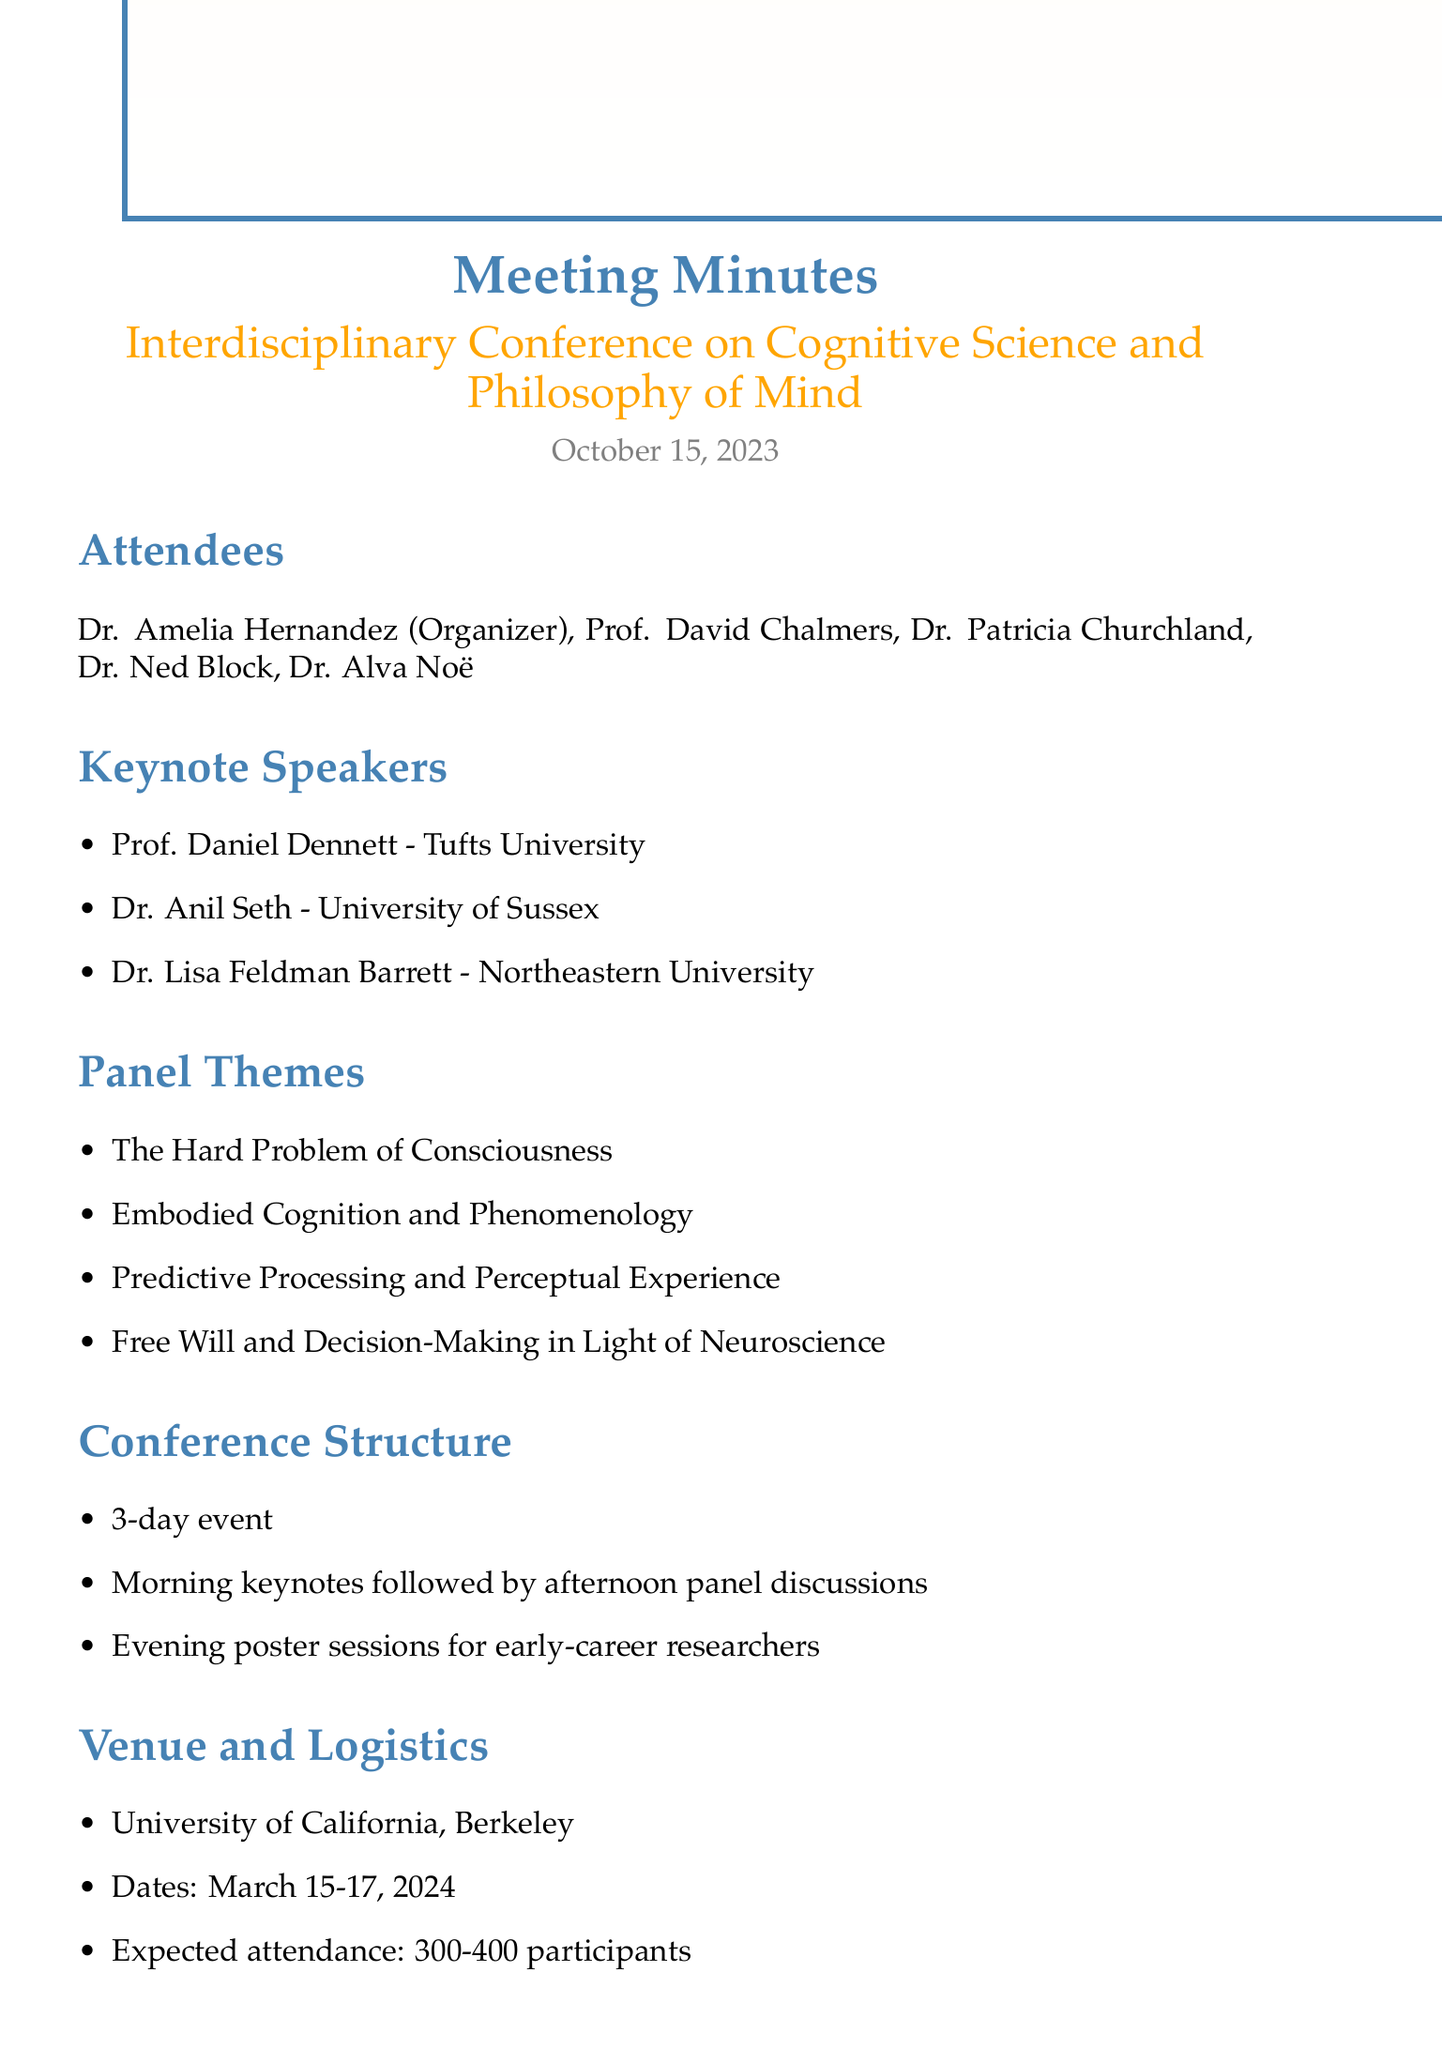What is the date of the conference? The conference dates are listed under the Venue and Logistics section of the document.
Answer: March 15-17, 2024 Who is the organizer of the conference? The organizer's name is mentioned at the beginning of the document.
Answer: Dr. Amelia Hernandez Which university is hosting the conference? The venue is stated in the Venue and Logistics section of the document.
Answer: University of California, Berkeley What are the names of the keynote speakers? The keynote speakers are listed in the Keynote Speakers section of the document.
Answer: Prof. Daniel Dennett, Dr. Anil Seth, Dr. Lisa Feldman Barrett How many participants are expected to attend the conference? The expected attendance is provided in the Venue and Logistics section.
Answer: 300-400 participants What is the first action item due date? The action items are numbered and the first one specifies the due date.
Answer: November 1, 2023 What is the theme of one of the panels? The panel themes are listed, and any one of them can be used as an answer.
Answer: The Hard Problem of Consciousness What special consideration emphasizes a specific aspect of research? The Special Considerations section highlights a specific focus for the conference.
Answer: Emphasize subjective experience in cognitive science research How long is the conference scheduled to last? The duration of the conference is mentioned within the Conference Structure section.
Answer: 3-day event 